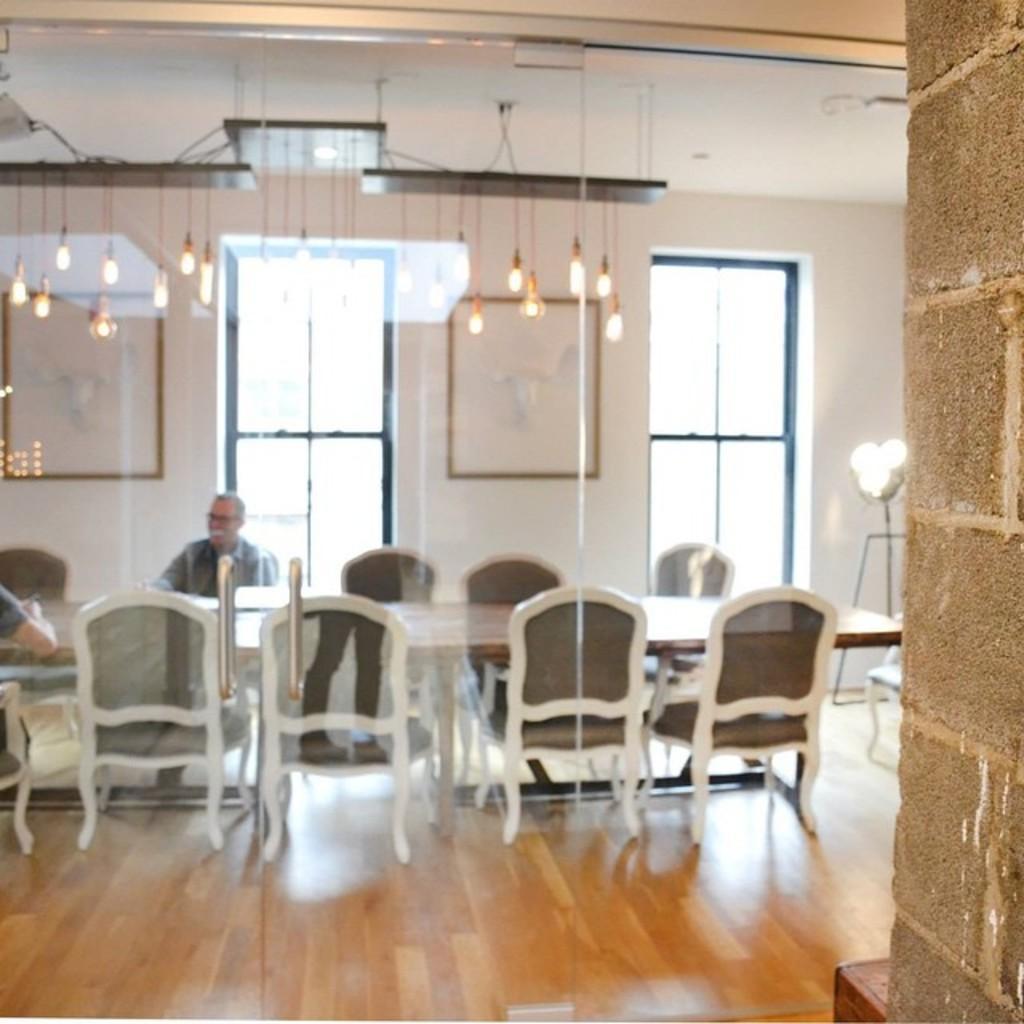Can you describe this image briefly? In this image in the front there is a glass and behind the glass there is a table and there are empty chairs and there are persons sitting on the chair. In the background there are windows and there are frames on the wall and on the top there are lights hanging. On the right side there is a light and there is a wall. 